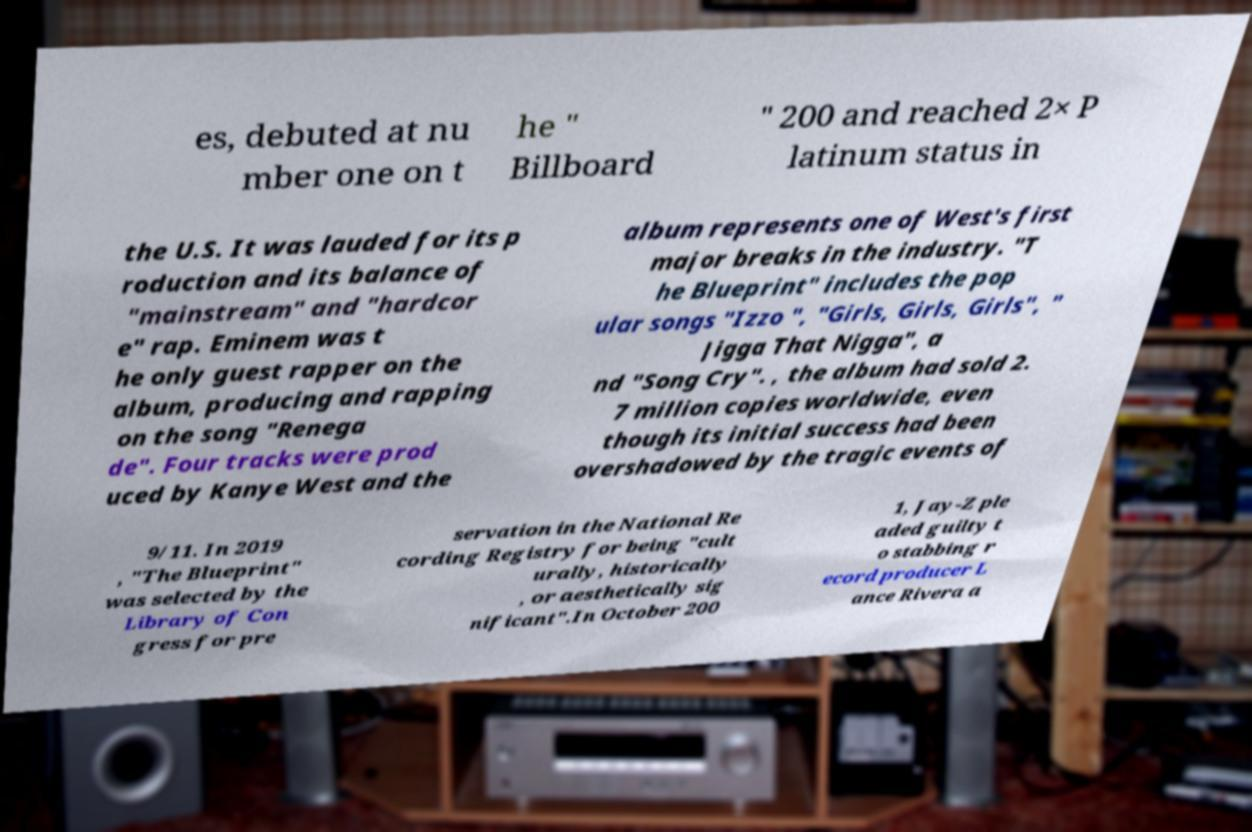Can you accurately transcribe the text from the provided image for me? es, debuted at nu mber one on t he " Billboard " 200 and reached 2× P latinum status in the U.S. It was lauded for its p roduction and its balance of "mainstream" and "hardcor e" rap. Eminem was t he only guest rapper on the album, producing and rapping on the song "Renega de". Four tracks were prod uced by Kanye West and the album represents one of West's first major breaks in the industry. "T he Blueprint" includes the pop ular songs "Izzo ", "Girls, Girls, Girls", " Jigga That Nigga", a nd "Song Cry". , the album had sold 2. 7 million copies worldwide, even though its initial success had been overshadowed by the tragic events of 9/11. In 2019 , "The Blueprint" was selected by the Library of Con gress for pre servation in the National Re cording Registry for being "cult urally, historically , or aesthetically sig nificant".In October 200 1, Jay-Z ple aded guilty t o stabbing r ecord producer L ance Rivera a 